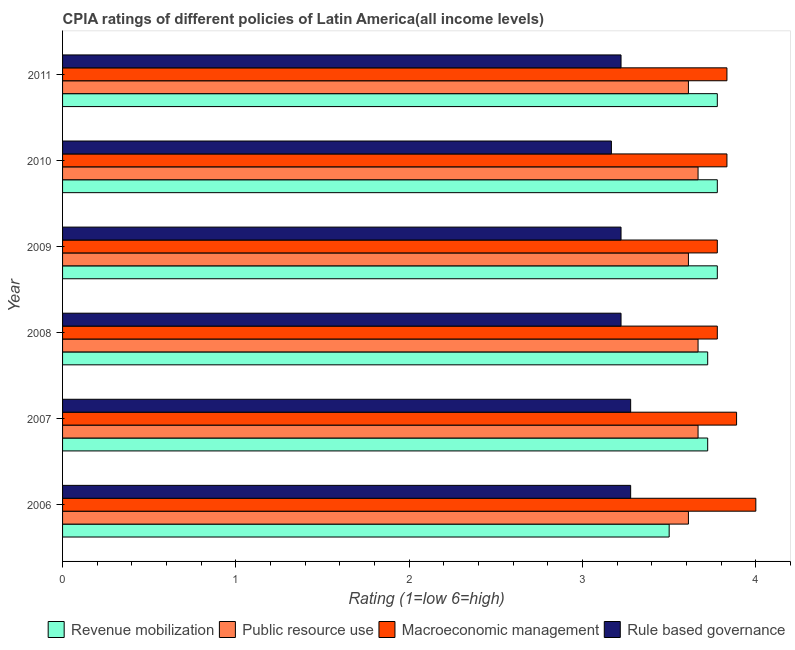How many groups of bars are there?
Offer a terse response. 6. Are the number of bars per tick equal to the number of legend labels?
Provide a succinct answer. Yes. Are the number of bars on each tick of the Y-axis equal?
Your response must be concise. Yes. How many bars are there on the 4th tick from the top?
Keep it short and to the point. 4. What is the cpia rating of revenue mobilization in 2009?
Your response must be concise. 3.78. Across all years, what is the maximum cpia rating of public resource use?
Make the answer very short. 3.67. Across all years, what is the minimum cpia rating of revenue mobilization?
Your answer should be compact. 3.5. In which year was the cpia rating of rule based governance maximum?
Offer a very short reply. 2006. In which year was the cpia rating of macroeconomic management minimum?
Your answer should be very brief. 2008. What is the total cpia rating of revenue mobilization in the graph?
Your response must be concise. 22.28. What is the difference between the cpia rating of rule based governance in 2008 and that in 2010?
Your answer should be compact. 0.06. What is the difference between the cpia rating of macroeconomic management in 2009 and the cpia rating of rule based governance in 2007?
Your answer should be compact. 0.5. What is the average cpia rating of revenue mobilization per year?
Your answer should be compact. 3.71. In the year 2007, what is the difference between the cpia rating of macroeconomic management and cpia rating of rule based governance?
Offer a very short reply. 0.61. What is the ratio of the cpia rating of public resource use in 2006 to that in 2010?
Your answer should be very brief. 0.98. Is the difference between the cpia rating of macroeconomic management in 2010 and 2011 greater than the difference between the cpia rating of public resource use in 2010 and 2011?
Your response must be concise. No. What is the difference between the highest and the second highest cpia rating of public resource use?
Keep it short and to the point. 0. What is the difference between the highest and the lowest cpia rating of macroeconomic management?
Your response must be concise. 0.22. In how many years, is the cpia rating of public resource use greater than the average cpia rating of public resource use taken over all years?
Provide a short and direct response. 3. Is the sum of the cpia rating of macroeconomic management in 2008 and 2011 greater than the maximum cpia rating of revenue mobilization across all years?
Your answer should be compact. Yes. Is it the case that in every year, the sum of the cpia rating of revenue mobilization and cpia rating of macroeconomic management is greater than the sum of cpia rating of rule based governance and cpia rating of public resource use?
Make the answer very short. Yes. What does the 2nd bar from the top in 2007 represents?
Your answer should be very brief. Macroeconomic management. What does the 4th bar from the bottom in 2009 represents?
Your answer should be very brief. Rule based governance. Is it the case that in every year, the sum of the cpia rating of revenue mobilization and cpia rating of public resource use is greater than the cpia rating of macroeconomic management?
Your response must be concise. Yes. Are all the bars in the graph horizontal?
Your answer should be compact. Yes. How many years are there in the graph?
Your answer should be very brief. 6. What is the difference between two consecutive major ticks on the X-axis?
Make the answer very short. 1. Where does the legend appear in the graph?
Provide a short and direct response. Bottom right. How many legend labels are there?
Your answer should be very brief. 4. What is the title of the graph?
Offer a very short reply. CPIA ratings of different policies of Latin America(all income levels). Does "Secondary schools" appear as one of the legend labels in the graph?
Give a very brief answer. No. What is the label or title of the X-axis?
Offer a terse response. Rating (1=low 6=high). What is the label or title of the Y-axis?
Your answer should be compact. Year. What is the Rating (1=low 6=high) in Public resource use in 2006?
Give a very brief answer. 3.61. What is the Rating (1=low 6=high) in Rule based governance in 2006?
Keep it short and to the point. 3.28. What is the Rating (1=low 6=high) of Revenue mobilization in 2007?
Your response must be concise. 3.72. What is the Rating (1=low 6=high) in Public resource use in 2007?
Ensure brevity in your answer.  3.67. What is the Rating (1=low 6=high) of Macroeconomic management in 2007?
Offer a very short reply. 3.89. What is the Rating (1=low 6=high) in Rule based governance in 2007?
Make the answer very short. 3.28. What is the Rating (1=low 6=high) in Revenue mobilization in 2008?
Provide a short and direct response. 3.72. What is the Rating (1=low 6=high) in Public resource use in 2008?
Give a very brief answer. 3.67. What is the Rating (1=low 6=high) in Macroeconomic management in 2008?
Your response must be concise. 3.78. What is the Rating (1=low 6=high) in Rule based governance in 2008?
Provide a short and direct response. 3.22. What is the Rating (1=low 6=high) in Revenue mobilization in 2009?
Offer a very short reply. 3.78. What is the Rating (1=low 6=high) in Public resource use in 2009?
Make the answer very short. 3.61. What is the Rating (1=low 6=high) of Macroeconomic management in 2009?
Provide a succinct answer. 3.78. What is the Rating (1=low 6=high) in Rule based governance in 2009?
Your answer should be very brief. 3.22. What is the Rating (1=low 6=high) in Revenue mobilization in 2010?
Keep it short and to the point. 3.78. What is the Rating (1=low 6=high) in Public resource use in 2010?
Keep it short and to the point. 3.67. What is the Rating (1=low 6=high) in Macroeconomic management in 2010?
Make the answer very short. 3.83. What is the Rating (1=low 6=high) in Rule based governance in 2010?
Your answer should be very brief. 3.17. What is the Rating (1=low 6=high) of Revenue mobilization in 2011?
Make the answer very short. 3.78. What is the Rating (1=low 6=high) of Public resource use in 2011?
Keep it short and to the point. 3.61. What is the Rating (1=low 6=high) of Macroeconomic management in 2011?
Your answer should be compact. 3.83. What is the Rating (1=low 6=high) of Rule based governance in 2011?
Make the answer very short. 3.22. Across all years, what is the maximum Rating (1=low 6=high) of Revenue mobilization?
Your answer should be very brief. 3.78. Across all years, what is the maximum Rating (1=low 6=high) of Public resource use?
Offer a terse response. 3.67. Across all years, what is the maximum Rating (1=low 6=high) in Macroeconomic management?
Offer a terse response. 4. Across all years, what is the maximum Rating (1=low 6=high) in Rule based governance?
Provide a succinct answer. 3.28. Across all years, what is the minimum Rating (1=low 6=high) in Public resource use?
Keep it short and to the point. 3.61. Across all years, what is the minimum Rating (1=low 6=high) of Macroeconomic management?
Give a very brief answer. 3.78. Across all years, what is the minimum Rating (1=low 6=high) of Rule based governance?
Ensure brevity in your answer.  3.17. What is the total Rating (1=low 6=high) in Revenue mobilization in the graph?
Make the answer very short. 22.28. What is the total Rating (1=low 6=high) of Public resource use in the graph?
Keep it short and to the point. 21.83. What is the total Rating (1=low 6=high) of Macroeconomic management in the graph?
Keep it short and to the point. 23.11. What is the total Rating (1=low 6=high) of Rule based governance in the graph?
Offer a very short reply. 19.39. What is the difference between the Rating (1=low 6=high) in Revenue mobilization in 2006 and that in 2007?
Your answer should be very brief. -0.22. What is the difference between the Rating (1=low 6=high) of Public resource use in 2006 and that in 2007?
Provide a succinct answer. -0.06. What is the difference between the Rating (1=low 6=high) in Macroeconomic management in 2006 and that in 2007?
Your answer should be compact. 0.11. What is the difference between the Rating (1=low 6=high) in Rule based governance in 2006 and that in 2007?
Offer a very short reply. 0. What is the difference between the Rating (1=low 6=high) of Revenue mobilization in 2006 and that in 2008?
Offer a terse response. -0.22. What is the difference between the Rating (1=low 6=high) of Public resource use in 2006 and that in 2008?
Give a very brief answer. -0.06. What is the difference between the Rating (1=low 6=high) in Macroeconomic management in 2006 and that in 2008?
Your answer should be very brief. 0.22. What is the difference between the Rating (1=low 6=high) in Rule based governance in 2006 and that in 2008?
Your answer should be very brief. 0.06. What is the difference between the Rating (1=low 6=high) in Revenue mobilization in 2006 and that in 2009?
Your answer should be very brief. -0.28. What is the difference between the Rating (1=low 6=high) in Public resource use in 2006 and that in 2009?
Keep it short and to the point. 0. What is the difference between the Rating (1=low 6=high) in Macroeconomic management in 2006 and that in 2009?
Keep it short and to the point. 0.22. What is the difference between the Rating (1=low 6=high) in Rule based governance in 2006 and that in 2009?
Provide a short and direct response. 0.06. What is the difference between the Rating (1=low 6=high) in Revenue mobilization in 2006 and that in 2010?
Offer a very short reply. -0.28. What is the difference between the Rating (1=low 6=high) of Public resource use in 2006 and that in 2010?
Offer a very short reply. -0.06. What is the difference between the Rating (1=low 6=high) in Revenue mobilization in 2006 and that in 2011?
Ensure brevity in your answer.  -0.28. What is the difference between the Rating (1=low 6=high) in Public resource use in 2006 and that in 2011?
Your response must be concise. 0. What is the difference between the Rating (1=low 6=high) of Rule based governance in 2006 and that in 2011?
Ensure brevity in your answer.  0.06. What is the difference between the Rating (1=low 6=high) of Revenue mobilization in 2007 and that in 2008?
Keep it short and to the point. 0. What is the difference between the Rating (1=low 6=high) in Macroeconomic management in 2007 and that in 2008?
Your answer should be compact. 0.11. What is the difference between the Rating (1=low 6=high) in Rule based governance in 2007 and that in 2008?
Give a very brief answer. 0.06. What is the difference between the Rating (1=low 6=high) in Revenue mobilization in 2007 and that in 2009?
Make the answer very short. -0.06. What is the difference between the Rating (1=low 6=high) of Public resource use in 2007 and that in 2009?
Ensure brevity in your answer.  0.06. What is the difference between the Rating (1=low 6=high) of Macroeconomic management in 2007 and that in 2009?
Offer a very short reply. 0.11. What is the difference between the Rating (1=low 6=high) in Rule based governance in 2007 and that in 2009?
Make the answer very short. 0.06. What is the difference between the Rating (1=low 6=high) in Revenue mobilization in 2007 and that in 2010?
Your response must be concise. -0.06. What is the difference between the Rating (1=low 6=high) in Public resource use in 2007 and that in 2010?
Keep it short and to the point. 0. What is the difference between the Rating (1=low 6=high) in Macroeconomic management in 2007 and that in 2010?
Your answer should be compact. 0.06. What is the difference between the Rating (1=low 6=high) in Revenue mobilization in 2007 and that in 2011?
Offer a very short reply. -0.06. What is the difference between the Rating (1=low 6=high) in Public resource use in 2007 and that in 2011?
Your answer should be compact. 0.06. What is the difference between the Rating (1=low 6=high) of Macroeconomic management in 2007 and that in 2011?
Offer a very short reply. 0.06. What is the difference between the Rating (1=low 6=high) in Rule based governance in 2007 and that in 2011?
Give a very brief answer. 0.06. What is the difference between the Rating (1=low 6=high) in Revenue mobilization in 2008 and that in 2009?
Your response must be concise. -0.06. What is the difference between the Rating (1=low 6=high) in Public resource use in 2008 and that in 2009?
Your response must be concise. 0.06. What is the difference between the Rating (1=low 6=high) of Revenue mobilization in 2008 and that in 2010?
Ensure brevity in your answer.  -0.06. What is the difference between the Rating (1=low 6=high) of Public resource use in 2008 and that in 2010?
Your response must be concise. 0. What is the difference between the Rating (1=low 6=high) in Macroeconomic management in 2008 and that in 2010?
Offer a terse response. -0.06. What is the difference between the Rating (1=low 6=high) of Rule based governance in 2008 and that in 2010?
Your response must be concise. 0.06. What is the difference between the Rating (1=low 6=high) of Revenue mobilization in 2008 and that in 2011?
Provide a succinct answer. -0.06. What is the difference between the Rating (1=low 6=high) of Public resource use in 2008 and that in 2011?
Your response must be concise. 0.06. What is the difference between the Rating (1=low 6=high) in Macroeconomic management in 2008 and that in 2011?
Give a very brief answer. -0.06. What is the difference between the Rating (1=low 6=high) of Rule based governance in 2008 and that in 2011?
Offer a terse response. 0. What is the difference between the Rating (1=low 6=high) of Revenue mobilization in 2009 and that in 2010?
Your answer should be compact. 0. What is the difference between the Rating (1=low 6=high) in Public resource use in 2009 and that in 2010?
Offer a very short reply. -0.06. What is the difference between the Rating (1=low 6=high) in Macroeconomic management in 2009 and that in 2010?
Your answer should be very brief. -0.06. What is the difference between the Rating (1=low 6=high) of Rule based governance in 2009 and that in 2010?
Give a very brief answer. 0.06. What is the difference between the Rating (1=low 6=high) in Public resource use in 2009 and that in 2011?
Offer a very short reply. 0. What is the difference between the Rating (1=low 6=high) in Macroeconomic management in 2009 and that in 2011?
Provide a short and direct response. -0.06. What is the difference between the Rating (1=low 6=high) in Public resource use in 2010 and that in 2011?
Your response must be concise. 0.06. What is the difference between the Rating (1=low 6=high) in Macroeconomic management in 2010 and that in 2011?
Provide a succinct answer. 0. What is the difference between the Rating (1=low 6=high) of Rule based governance in 2010 and that in 2011?
Provide a short and direct response. -0.06. What is the difference between the Rating (1=low 6=high) in Revenue mobilization in 2006 and the Rating (1=low 6=high) in Public resource use in 2007?
Your response must be concise. -0.17. What is the difference between the Rating (1=low 6=high) in Revenue mobilization in 2006 and the Rating (1=low 6=high) in Macroeconomic management in 2007?
Provide a succinct answer. -0.39. What is the difference between the Rating (1=low 6=high) of Revenue mobilization in 2006 and the Rating (1=low 6=high) of Rule based governance in 2007?
Offer a very short reply. 0.22. What is the difference between the Rating (1=low 6=high) of Public resource use in 2006 and the Rating (1=low 6=high) of Macroeconomic management in 2007?
Ensure brevity in your answer.  -0.28. What is the difference between the Rating (1=low 6=high) in Macroeconomic management in 2006 and the Rating (1=low 6=high) in Rule based governance in 2007?
Offer a terse response. 0.72. What is the difference between the Rating (1=low 6=high) in Revenue mobilization in 2006 and the Rating (1=low 6=high) in Macroeconomic management in 2008?
Provide a short and direct response. -0.28. What is the difference between the Rating (1=low 6=high) of Revenue mobilization in 2006 and the Rating (1=low 6=high) of Rule based governance in 2008?
Ensure brevity in your answer.  0.28. What is the difference between the Rating (1=low 6=high) of Public resource use in 2006 and the Rating (1=low 6=high) of Rule based governance in 2008?
Offer a terse response. 0.39. What is the difference between the Rating (1=low 6=high) in Revenue mobilization in 2006 and the Rating (1=low 6=high) in Public resource use in 2009?
Offer a terse response. -0.11. What is the difference between the Rating (1=low 6=high) in Revenue mobilization in 2006 and the Rating (1=low 6=high) in Macroeconomic management in 2009?
Your response must be concise. -0.28. What is the difference between the Rating (1=low 6=high) in Revenue mobilization in 2006 and the Rating (1=low 6=high) in Rule based governance in 2009?
Offer a very short reply. 0.28. What is the difference between the Rating (1=low 6=high) in Public resource use in 2006 and the Rating (1=low 6=high) in Rule based governance in 2009?
Ensure brevity in your answer.  0.39. What is the difference between the Rating (1=low 6=high) of Revenue mobilization in 2006 and the Rating (1=low 6=high) of Public resource use in 2010?
Offer a very short reply. -0.17. What is the difference between the Rating (1=low 6=high) of Revenue mobilization in 2006 and the Rating (1=low 6=high) of Macroeconomic management in 2010?
Keep it short and to the point. -0.33. What is the difference between the Rating (1=low 6=high) of Public resource use in 2006 and the Rating (1=low 6=high) of Macroeconomic management in 2010?
Make the answer very short. -0.22. What is the difference between the Rating (1=low 6=high) in Public resource use in 2006 and the Rating (1=low 6=high) in Rule based governance in 2010?
Your response must be concise. 0.44. What is the difference between the Rating (1=low 6=high) of Macroeconomic management in 2006 and the Rating (1=low 6=high) of Rule based governance in 2010?
Give a very brief answer. 0.83. What is the difference between the Rating (1=low 6=high) in Revenue mobilization in 2006 and the Rating (1=low 6=high) in Public resource use in 2011?
Your answer should be compact. -0.11. What is the difference between the Rating (1=low 6=high) of Revenue mobilization in 2006 and the Rating (1=low 6=high) of Macroeconomic management in 2011?
Your answer should be compact. -0.33. What is the difference between the Rating (1=low 6=high) of Revenue mobilization in 2006 and the Rating (1=low 6=high) of Rule based governance in 2011?
Ensure brevity in your answer.  0.28. What is the difference between the Rating (1=low 6=high) in Public resource use in 2006 and the Rating (1=low 6=high) in Macroeconomic management in 2011?
Ensure brevity in your answer.  -0.22. What is the difference between the Rating (1=low 6=high) of Public resource use in 2006 and the Rating (1=low 6=high) of Rule based governance in 2011?
Ensure brevity in your answer.  0.39. What is the difference between the Rating (1=low 6=high) of Revenue mobilization in 2007 and the Rating (1=low 6=high) of Public resource use in 2008?
Ensure brevity in your answer.  0.06. What is the difference between the Rating (1=low 6=high) in Revenue mobilization in 2007 and the Rating (1=low 6=high) in Macroeconomic management in 2008?
Offer a terse response. -0.06. What is the difference between the Rating (1=low 6=high) of Public resource use in 2007 and the Rating (1=low 6=high) of Macroeconomic management in 2008?
Your answer should be very brief. -0.11. What is the difference between the Rating (1=low 6=high) of Public resource use in 2007 and the Rating (1=low 6=high) of Rule based governance in 2008?
Your answer should be compact. 0.44. What is the difference between the Rating (1=low 6=high) in Revenue mobilization in 2007 and the Rating (1=low 6=high) in Macroeconomic management in 2009?
Offer a very short reply. -0.06. What is the difference between the Rating (1=low 6=high) in Public resource use in 2007 and the Rating (1=low 6=high) in Macroeconomic management in 2009?
Give a very brief answer. -0.11. What is the difference between the Rating (1=low 6=high) in Public resource use in 2007 and the Rating (1=low 6=high) in Rule based governance in 2009?
Keep it short and to the point. 0.44. What is the difference between the Rating (1=low 6=high) in Revenue mobilization in 2007 and the Rating (1=low 6=high) in Public resource use in 2010?
Your answer should be very brief. 0.06. What is the difference between the Rating (1=low 6=high) of Revenue mobilization in 2007 and the Rating (1=low 6=high) of Macroeconomic management in 2010?
Your response must be concise. -0.11. What is the difference between the Rating (1=low 6=high) of Revenue mobilization in 2007 and the Rating (1=low 6=high) of Rule based governance in 2010?
Keep it short and to the point. 0.56. What is the difference between the Rating (1=low 6=high) of Public resource use in 2007 and the Rating (1=low 6=high) of Macroeconomic management in 2010?
Offer a very short reply. -0.17. What is the difference between the Rating (1=low 6=high) of Macroeconomic management in 2007 and the Rating (1=low 6=high) of Rule based governance in 2010?
Provide a succinct answer. 0.72. What is the difference between the Rating (1=low 6=high) in Revenue mobilization in 2007 and the Rating (1=low 6=high) in Public resource use in 2011?
Give a very brief answer. 0.11. What is the difference between the Rating (1=low 6=high) in Revenue mobilization in 2007 and the Rating (1=low 6=high) in Macroeconomic management in 2011?
Give a very brief answer. -0.11. What is the difference between the Rating (1=low 6=high) in Revenue mobilization in 2007 and the Rating (1=low 6=high) in Rule based governance in 2011?
Provide a short and direct response. 0.5. What is the difference between the Rating (1=low 6=high) of Public resource use in 2007 and the Rating (1=low 6=high) of Macroeconomic management in 2011?
Give a very brief answer. -0.17. What is the difference between the Rating (1=low 6=high) of Public resource use in 2007 and the Rating (1=low 6=high) of Rule based governance in 2011?
Provide a short and direct response. 0.44. What is the difference between the Rating (1=low 6=high) in Revenue mobilization in 2008 and the Rating (1=low 6=high) in Public resource use in 2009?
Your answer should be very brief. 0.11. What is the difference between the Rating (1=low 6=high) in Revenue mobilization in 2008 and the Rating (1=low 6=high) in Macroeconomic management in 2009?
Your answer should be compact. -0.06. What is the difference between the Rating (1=low 6=high) of Revenue mobilization in 2008 and the Rating (1=low 6=high) of Rule based governance in 2009?
Your response must be concise. 0.5. What is the difference between the Rating (1=low 6=high) in Public resource use in 2008 and the Rating (1=low 6=high) in Macroeconomic management in 2009?
Keep it short and to the point. -0.11. What is the difference between the Rating (1=low 6=high) of Public resource use in 2008 and the Rating (1=low 6=high) of Rule based governance in 2009?
Provide a succinct answer. 0.44. What is the difference between the Rating (1=low 6=high) in Macroeconomic management in 2008 and the Rating (1=low 6=high) in Rule based governance in 2009?
Your response must be concise. 0.56. What is the difference between the Rating (1=low 6=high) in Revenue mobilization in 2008 and the Rating (1=low 6=high) in Public resource use in 2010?
Your answer should be very brief. 0.06. What is the difference between the Rating (1=low 6=high) of Revenue mobilization in 2008 and the Rating (1=low 6=high) of Macroeconomic management in 2010?
Give a very brief answer. -0.11. What is the difference between the Rating (1=low 6=high) in Revenue mobilization in 2008 and the Rating (1=low 6=high) in Rule based governance in 2010?
Offer a terse response. 0.56. What is the difference between the Rating (1=low 6=high) of Public resource use in 2008 and the Rating (1=low 6=high) of Macroeconomic management in 2010?
Make the answer very short. -0.17. What is the difference between the Rating (1=low 6=high) in Public resource use in 2008 and the Rating (1=low 6=high) in Rule based governance in 2010?
Your response must be concise. 0.5. What is the difference between the Rating (1=low 6=high) in Macroeconomic management in 2008 and the Rating (1=low 6=high) in Rule based governance in 2010?
Your answer should be very brief. 0.61. What is the difference between the Rating (1=low 6=high) in Revenue mobilization in 2008 and the Rating (1=low 6=high) in Macroeconomic management in 2011?
Your response must be concise. -0.11. What is the difference between the Rating (1=low 6=high) in Public resource use in 2008 and the Rating (1=low 6=high) in Rule based governance in 2011?
Give a very brief answer. 0.44. What is the difference between the Rating (1=low 6=high) of Macroeconomic management in 2008 and the Rating (1=low 6=high) of Rule based governance in 2011?
Offer a terse response. 0.56. What is the difference between the Rating (1=low 6=high) in Revenue mobilization in 2009 and the Rating (1=low 6=high) in Public resource use in 2010?
Offer a very short reply. 0.11. What is the difference between the Rating (1=low 6=high) of Revenue mobilization in 2009 and the Rating (1=low 6=high) of Macroeconomic management in 2010?
Ensure brevity in your answer.  -0.06. What is the difference between the Rating (1=low 6=high) of Revenue mobilization in 2009 and the Rating (1=low 6=high) of Rule based governance in 2010?
Provide a short and direct response. 0.61. What is the difference between the Rating (1=low 6=high) of Public resource use in 2009 and the Rating (1=low 6=high) of Macroeconomic management in 2010?
Offer a very short reply. -0.22. What is the difference between the Rating (1=low 6=high) of Public resource use in 2009 and the Rating (1=low 6=high) of Rule based governance in 2010?
Offer a very short reply. 0.44. What is the difference between the Rating (1=low 6=high) in Macroeconomic management in 2009 and the Rating (1=low 6=high) in Rule based governance in 2010?
Your answer should be compact. 0.61. What is the difference between the Rating (1=low 6=high) in Revenue mobilization in 2009 and the Rating (1=low 6=high) in Public resource use in 2011?
Give a very brief answer. 0.17. What is the difference between the Rating (1=low 6=high) in Revenue mobilization in 2009 and the Rating (1=low 6=high) in Macroeconomic management in 2011?
Offer a very short reply. -0.06. What is the difference between the Rating (1=low 6=high) of Revenue mobilization in 2009 and the Rating (1=low 6=high) of Rule based governance in 2011?
Provide a short and direct response. 0.56. What is the difference between the Rating (1=low 6=high) of Public resource use in 2009 and the Rating (1=low 6=high) of Macroeconomic management in 2011?
Offer a terse response. -0.22. What is the difference between the Rating (1=low 6=high) in Public resource use in 2009 and the Rating (1=low 6=high) in Rule based governance in 2011?
Keep it short and to the point. 0.39. What is the difference between the Rating (1=low 6=high) of Macroeconomic management in 2009 and the Rating (1=low 6=high) of Rule based governance in 2011?
Offer a very short reply. 0.56. What is the difference between the Rating (1=low 6=high) in Revenue mobilization in 2010 and the Rating (1=low 6=high) in Macroeconomic management in 2011?
Offer a terse response. -0.06. What is the difference between the Rating (1=low 6=high) of Revenue mobilization in 2010 and the Rating (1=low 6=high) of Rule based governance in 2011?
Provide a short and direct response. 0.56. What is the difference between the Rating (1=low 6=high) of Public resource use in 2010 and the Rating (1=low 6=high) of Macroeconomic management in 2011?
Provide a short and direct response. -0.17. What is the difference between the Rating (1=low 6=high) of Public resource use in 2010 and the Rating (1=low 6=high) of Rule based governance in 2011?
Make the answer very short. 0.44. What is the difference between the Rating (1=low 6=high) of Macroeconomic management in 2010 and the Rating (1=low 6=high) of Rule based governance in 2011?
Keep it short and to the point. 0.61. What is the average Rating (1=low 6=high) of Revenue mobilization per year?
Provide a short and direct response. 3.71. What is the average Rating (1=low 6=high) in Public resource use per year?
Keep it short and to the point. 3.64. What is the average Rating (1=low 6=high) in Macroeconomic management per year?
Make the answer very short. 3.85. What is the average Rating (1=low 6=high) in Rule based governance per year?
Provide a succinct answer. 3.23. In the year 2006, what is the difference between the Rating (1=low 6=high) of Revenue mobilization and Rating (1=low 6=high) of Public resource use?
Ensure brevity in your answer.  -0.11. In the year 2006, what is the difference between the Rating (1=low 6=high) in Revenue mobilization and Rating (1=low 6=high) in Macroeconomic management?
Ensure brevity in your answer.  -0.5. In the year 2006, what is the difference between the Rating (1=low 6=high) of Revenue mobilization and Rating (1=low 6=high) of Rule based governance?
Offer a very short reply. 0.22. In the year 2006, what is the difference between the Rating (1=low 6=high) in Public resource use and Rating (1=low 6=high) in Macroeconomic management?
Provide a short and direct response. -0.39. In the year 2006, what is the difference between the Rating (1=low 6=high) of Macroeconomic management and Rating (1=low 6=high) of Rule based governance?
Provide a short and direct response. 0.72. In the year 2007, what is the difference between the Rating (1=low 6=high) of Revenue mobilization and Rating (1=low 6=high) of Public resource use?
Give a very brief answer. 0.06. In the year 2007, what is the difference between the Rating (1=low 6=high) in Revenue mobilization and Rating (1=low 6=high) in Macroeconomic management?
Offer a very short reply. -0.17. In the year 2007, what is the difference between the Rating (1=low 6=high) of Revenue mobilization and Rating (1=low 6=high) of Rule based governance?
Your answer should be compact. 0.44. In the year 2007, what is the difference between the Rating (1=low 6=high) of Public resource use and Rating (1=low 6=high) of Macroeconomic management?
Offer a terse response. -0.22. In the year 2007, what is the difference between the Rating (1=low 6=high) of Public resource use and Rating (1=low 6=high) of Rule based governance?
Offer a terse response. 0.39. In the year 2007, what is the difference between the Rating (1=low 6=high) of Macroeconomic management and Rating (1=low 6=high) of Rule based governance?
Provide a succinct answer. 0.61. In the year 2008, what is the difference between the Rating (1=low 6=high) of Revenue mobilization and Rating (1=low 6=high) of Public resource use?
Give a very brief answer. 0.06. In the year 2008, what is the difference between the Rating (1=low 6=high) in Revenue mobilization and Rating (1=low 6=high) in Macroeconomic management?
Provide a succinct answer. -0.06. In the year 2008, what is the difference between the Rating (1=low 6=high) in Revenue mobilization and Rating (1=low 6=high) in Rule based governance?
Offer a very short reply. 0.5. In the year 2008, what is the difference between the Rating (1=low 6=high) of Public resource use and Rating (1=low 6=high) of Macroeconomic management?
Your answer should be very brief. -0.11. In the year 2008, what is the difference between the Rating (1=low 6=high) in Public resource use and Rating (1=low 6=high) in Rule based governance?
Make the answer very short. 0.44. In the year 2008, what is the difference between the Rating (1=low 6=high) in Macroeconomic management and Rating (1=low 6=high) in Rule based governance?
Provide a succinct answer. 0.56. In the year 2009, what is the difference between the Rating (1=low 6=high) of Revenue mobilization and Rating (1=low 6=high) of Rule based governance?
Ensure brevity in your answer.  0.56. In the year 2009, what is the difference between the Rating (1=low 6=high) in Public resource use and Rating (1=low 6=high) in Macroeconomic management?
Keep it short and to the point. -0.17. In the year 2009, what is the difference between the Rating (1=low 6=high) in Public resource use and Rating (1=low 6=high) in Rule based governance?
Offer a very short reply. 0.39. In the year 2009, what is the difference between the Rating (1=low 6=high) of Macroeconomic management and Rating (1=low 6=high) of Rule based governance?
Your answer should be compact. 0.56. In the year 2010, what is the difference between the Rating (1=low 6=high) of Revenue mobilization and Rating (1=low 6=high) of Macroeconomic management?
Your answer should be very brief. -0.06. In the year 2010, what is the difference between the Rating (1=low 6=high) in Revenue mobilization and Rating (1=low 6=high) in Rule based governance?
Offer a very short reply. 0.61. In the year 2010, what is the difference between the Rating (1=low 6=high) in Public resource use and Rating (1=low 6=high) in Macroeconomic management?
Ensure brevity in your answer.  -0.17. In the year 2010, what is the difference between the Rating (1=low 6=high) of Public resource use and Rating (1=low 6=high) of Rule based governance?
Your response must be concise. 0.5. In the year 2011, what is the difference between the Rating (1=low 6=high) of Revenue mobilization and Rating (1=low 6=high) of Public resource use?
Offer a terse response. 0.17. In the year 2011, what is the difference between the Rating (1=low 6=high) in Revenue mobilization and Rating (1=low 6=high) in Macroeconomic management?
Offer a terse response. -0.06. In the year 2011, what is the difference between the Rating (1=low 6=high) in Revenue mobilization and Rating (1=low 6=high) in Rule based governance?
Give a very brief answer. 0.56. In the year 2011, what is the difference between the Rating (1=low 6=high) of Public resource use and Rating (1=low 6=high) of Macroeconomic management?
Keep it short and to the point. -0.22. In the year 2011, what is the difference between the Rating (1=low 6=high) of Public resource use and Rating (1=low 6=high) of Rule based governance?
Provide a short and direct response. 0.39. In the year 2011, what is the difference between the Rating (1=low 6=high) of Macroeconomic management and Rating (1=low 6=high) of Rule based governance?
Your answer should be very brief. 0.61. What is the ratio of the Rating (1=low 6=high) in Revenue mobilization in 2006 to that in 2007?
Your answer should be compact. 0.94. What is the ratio of the Rating (1=low 6=high) of Public resource use in 2006 to that in 2007?
Provide a succinct answer. 0.98. What is the ratio of the Rating (1=low 6=high) of Macroeconomic management in 2006 to that in 2007?
Provide a short and direct response. 1.03. What is the ratio of the Rating (1=low 6=high) in Revenue mobilization in 2006 to that in 2008?
Offer a very short reply. 0.94. What is the ratio of the Rating (1=low 6=high) in Public resource use in 2006 to that in 2008?
Your answer should be compact. 0.98. What is the ratio of the Rating (1=low 6=high) in Macroeconomic management in 2006 to that in 2008?
Your answer should be compact. 1.06. What is the ratio of the Rating (1=low 6=high) of Rule based governance in 2006 to that in 2008?
Make the answer very short. 1.02. What is the ratio of the Rating (1=low 6=high) in Revenue mobilization in 2006 to that in 2009?
Give a very brief answer. 0.93. What is the ratio of the Rating (1=low 6=high) of Public resource use in 2006 to that in 2009?
Provide a short and direct response. 1. What is the ratio of the Rating (1=low 6=high) of Macroeconomic management in 2006 to that in 2009?
Your answer should be compact. 1.06. What is the ratio of the Rating (1=low 6=high) of Rule based governance in 2006 to that in 2009?
Provide a short and direct response. 1.02. What is the ratio of the Rating (1=low 6=high) of Revenue mobilization in 2006 to that in 2010?
Provide a succinct answer. 0.93. What is the ratio of the Rating (1=low 6=high) of Macroeconomic management in 2006 to that in 2010?
Keep it short and to the point. 1.04. What is the ratio of the Rating (1=low 6=high) of Rule based governance in 2006 to that in 2010?
Give a very brief answer. 1.04. What is the ratio of the Rating (1=low 6=high) in Revenue mobilization in 2006 to that in 2011?
Make the answer very short. 0.93. What is the ratio of the Rating (1=low 6=high) of Public resource use in 2006 to that in 2011?
Provide a succinct answer. 1. What is the ratio of the Rating (1=low 6=high) in Macroeconomic management in 2006 to that in 2011?
Ensure brevity in your answer.  1.04. What is the ratio of the Rating (1=low 6=high) of Rule based governance in 2006 to that in 2011?
Your response must be concise. 1.02. What is the ratio of the Rating (1=low 6=high) in Revenue mobilization in 2007 to that in 2008?
Your response must be concise. 1. What is the ratio of the Rating (1=low 6=high) of Macroeconomic management in 2007 to that in 2008?
Offer a very short reply. 1.03. What is the ratio of the Rating (1=low 6=high) in Rule based governance in 2007 to that in 2008?
Offer a very short reply. 1.02. What is the ratio of the Rating (1=low 6=high) of Revenue mobilization in 2007 to that in 2009?
Provide a short and direct response. 0.99. What is the ratio of the Rating (1=low 6=high) of Public resource use in 2007 to that in 2009?
Ensure brevity in your answer.  1.02. What is the ratio of the Rating (1=low 6=high) of Macroeconomic management in 2007 to that in 2009?
Provide a short and direct response. 1.03. What is the ratio of the Rating (1=low 6=high) in Rule based governance in 2007 to that in 2009?
Make the answer very short. 1.02. What is the ratio of the Rating (1=low 6=high) of Revenue mobilization in 2007 to that in 2010?
Provide a succinct answer. 0.99. What is the ratio of the Rating (1=low 6=high) in Public resource use in 2007 to that in 2010?
Offer a very short reply. 1. What is the ratio of the Rating (1=low 6=high) in Macroeconomic management in 2007 to that in 2010?
Make the answer very short. 1.01. What is the ratio of the Rating (1=low 6=high) in Rule based governance in 2007 to that in 2010?
Provide a short and direct response. 1.04. What is the ratio of the Rating (1=low 6=high) in Revenue mobilization in 2007 to that in 2011?
Provide a short and direct response. 0.99. What is the ratio of the Rating (1=low 6=high) in Public resource use in 2007 to that in 2011?
Your response must be concise. 1.02. What is the ratio of the Rating (1=low 6=high) of Macroeconomic management in 2007 to that in 2011?
Offer a very short reply. 1.01. What is the ratio of the Rating (1=low 6=high) in Rule based governance in 2007 to that in 2011?
Your answer should be compact. 1.02. What is the ratio of the Rating (1=low 6=high) in Revenue mobilization in 2008 to that in 2009?
Provide a short and direct response. 0.99. What is the ratio of the Rating (1=low 6=high) in Public resource use in 2008 to that in 2009?
Make the answer very short. 1.02. What is the ratio of the Rating (1=low 6=high) in Rule based governance in 2008 to that in 2009?
Offer a terse response. 1. What is the ratio of the Rating (1=low 6=high) of Revenue mobilization in 2008 to that in 2010?
Your answer should be very brief. 0.99. What is the ratio of the Rating (1=low 6=high) in Public resource use in 2008 to that in 2010?
Keep it short and to the point. 1. What is the ratio of the Rating (1=low 6=high) of Macroeconomic management in 2008 to that in 2010?
Your answer should be compact. 0.99. What is the ratio of the Rating (1=low 6=high) in Rule based governance in 2008 to that in 2010?
Give a very brief answer. 1.02. What is the ratio of the Rating (1=low 6=high) in Revenue mobilization in 2008 to that in 2011?
Ensure brevity in your answer.  0.99. What is the ratio of the Rating (1=low 6=high) of Public resource use in 2008 to that in 2011?
Offer a terse response. 1.02. What is the ratio of the Rating (1=low 6=high) of Macroeconomic management in 2008 to that in 2011?
Give a very brief answer. 0.99. What is the ratio of the Rating (1=low 6=high) in Revenue mobilization in 2009 to that in 2010?
Your answer should be very brief. 1. What is the ratio of the Rating (1=low 6=high) in Public resource use in 2009 to that in 2010?
Make the answer very short. 0.98. What is the ratio of the Rating (1=low 6=high) in Macroeconomic management in 2009 to that in 2010?
Your answer should be very brief. 0.99. What is the ratio of the Rating (1=low 6=high) in Rule based governance in 2009 to that in 2010?
Offer a terse response. 1.02. What is the ratio of the Rating (1=low 6=high) in Macroeconomic management in 2009 to that in 2011?
Your answer should be very brief. 0.99. What is the ratio of the Rating (1=low 6=high) of Public resource use in 2010 to that in 2011?
Give a very brief answer. 1.02. What is the ratio of the Rating (1=low 6=high) of Macroeconomic management in 2010 to that in 2011?
Offer a terse response. 1. What is the ratio of the Rating (1=low 6=high) of Rule based governance in 2010 to that in 2011?
Keep it short and to the point. 0.98. What is the difference between the highest and the second highest Rating (1=low 6=high) in Public resource use?
Your response must be concise. 0. What is the difference between the highest and the second highest Rating (1=low 6=high) of Macroeconomic management?
Give a very brief answer. 0.11. What is the difference between the highest and the second highest Rating (1=low 6=high) of Rule based governance?
Your answer should be very brief. 0. What is the difference between the highest and the lowest Rating (1=low 6=high) of Revenue mobilization?
Offer a terse response. 0.28. What is the difference between the highest and the lowest Rating (1=low 6=high) in Public resource use?
Make the answer very short. 0.06. What is the difference between the highest and the lowest Rating (1=low 6=high) of Macroeconomic management?
Your response must be concise. 0.22. What is the difference between the highest and the lowest Rating (1=low 6=high) of Rule based governance?
Provide a short and direct response. 0.11. 